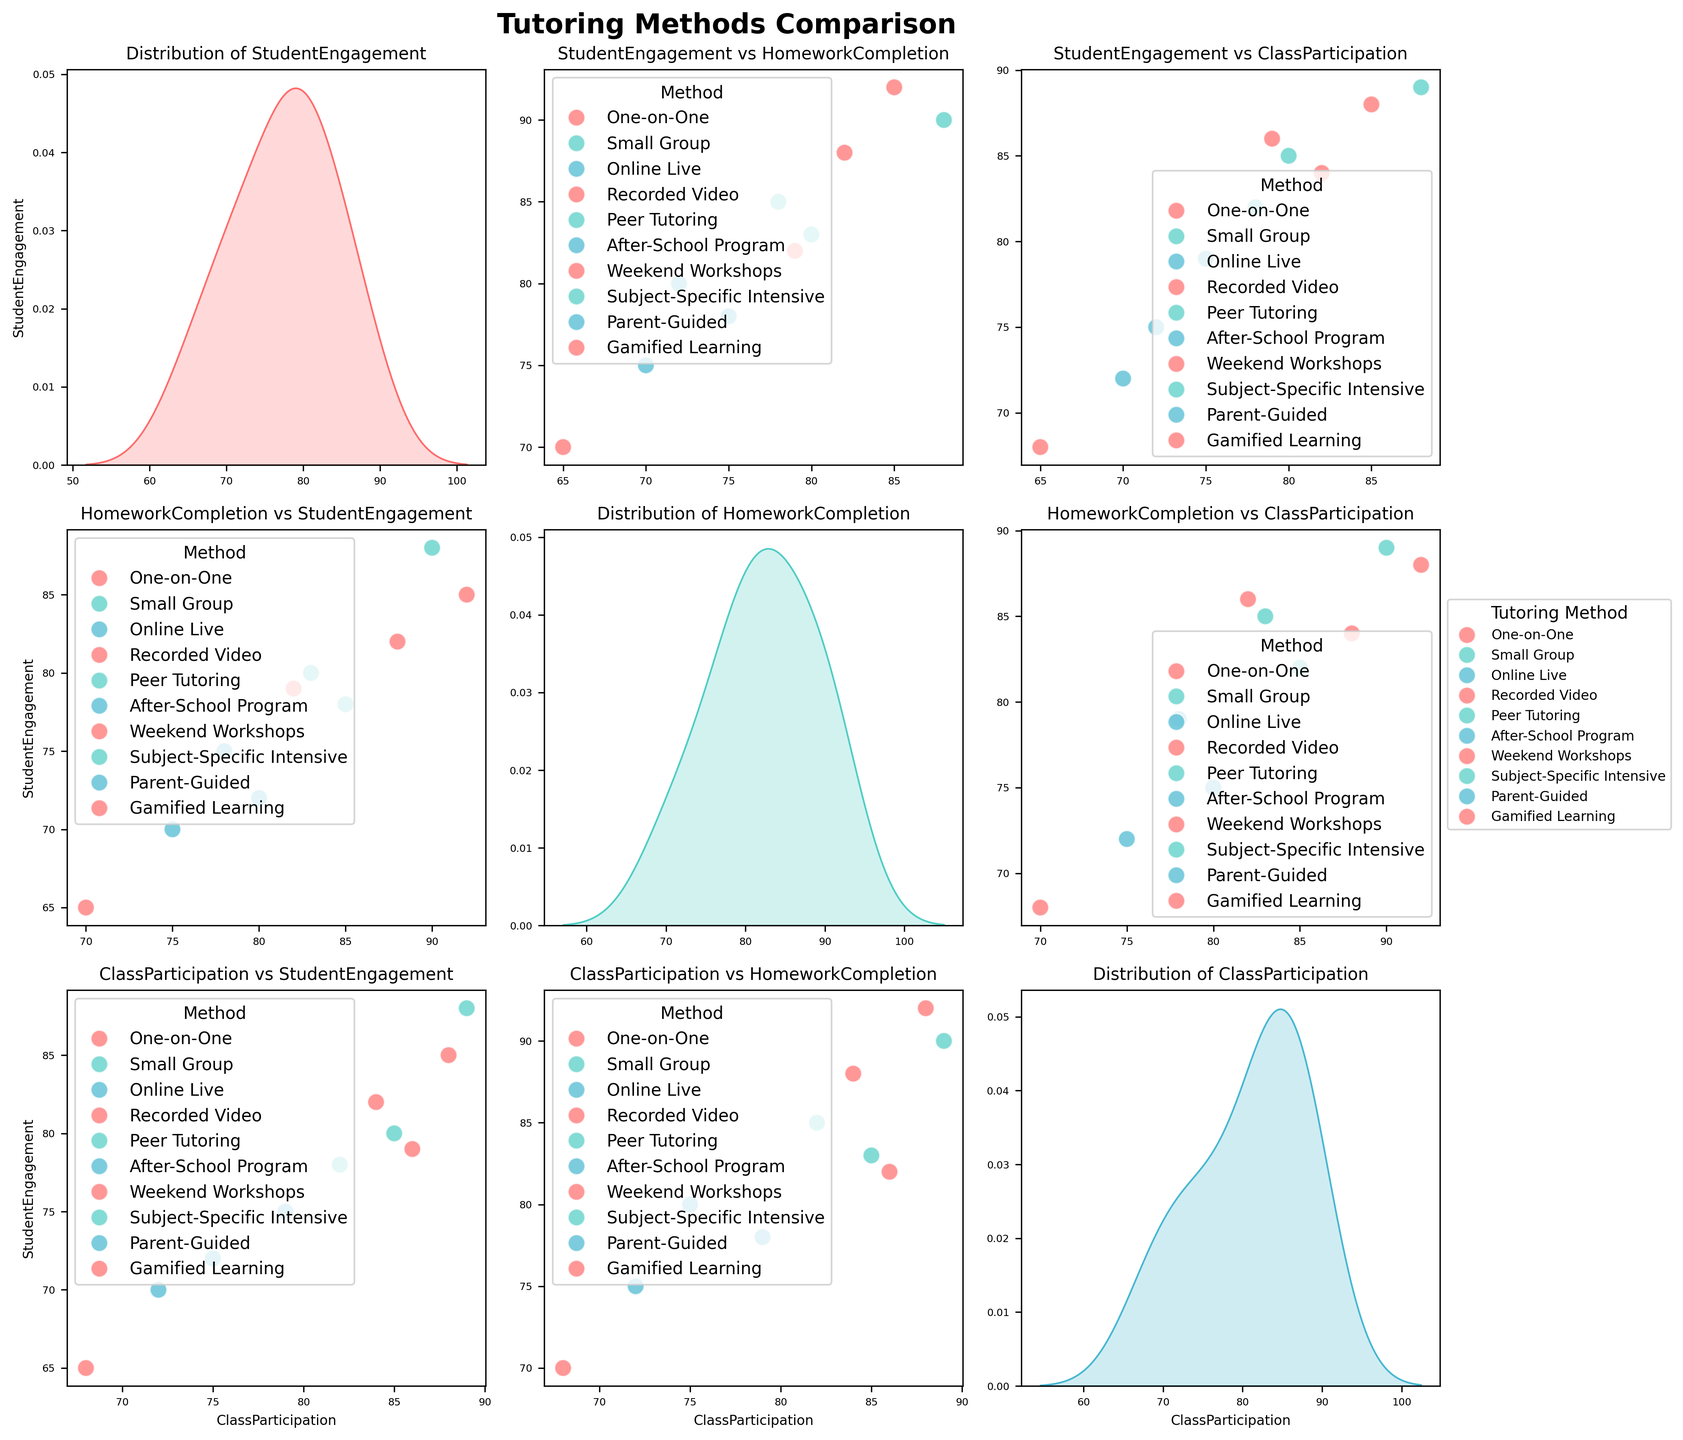What's the title of the figure? The title of the figure is written at the top, and it states "Tutoring Methods Comparison."
Answer: Tutoring Methods Comparison How many tutoring methods are compared in this scatterplot matrix? There are individual data points for each method in different parts of the plot, and each point is distinguished by its color and legend. Counting the labels in the legend, there are 10 tutoring methods.
Answer: 10 Which tutoring method has the highest student engagement? By observing the Student Engagement vs. other variables plots, the method with the highest engagement has a point close to 90. Checking the legend, Subject-Specific Intensive is highest with an engagement of 88.
Answer: Subject-Specific Intensive How does the class participation of Small Group compare to One-on-One? In the scatterplots where both Small Group and One-on-One appear, we see that Small Group has a class participation of 82, while One-on-One has 88. Thus, One-on-One has higher class participation.
Answer: One-on-One has higher Which two methods show the most similar trends in all three metrics: student engagement, homework completion, and class participation? Observing the scatterplots where data points cluster close to one another for both student engagement against homework completion and class participation, Peer Tutoring and Gamified Learning appear frequently close together in all combinations.
Answer: Peer Tutoring and Gamified Learning What is the average homework completion rate across all methods? The homework completion rates for all methods are: 92, 85, 80, 70, 83, 78, 88, 90, 75, 82. Summing these up yields 823. Dividing by the 10 methods gives an average of 823/10 = 82.3.
Answer: 82.3 Which method shows the lowest level of student engagement? Observing the Student Engagement distributions, the lowest value is near 65. The method associated with this value is Recorded Video.
Answer: Recorded Video What kind of point pattern or spread do you observe in the Student Engagement vs. Homework Completion plot? In the scatter plot of Student Engagement vs. Homework Completion, we see that the points show a positive trend, indicating that higher engagement correlates with higher homework completion rates, though there's some spread.
Answer: Positive correlation with some spread How does Online Live compare to Weekend Workshops in terms of class participation? By looking at the Class Participation values, Online Live has a value of 75, while Weekend Workshops has 84. Thus, Weekend Workshops has higher class participation.
Answer: Weekend Workshops has higher What would you infer about Subject-Specific Intensive's overall performance based on its position in various plots? Subject-Specific Intensive can be seen having high values in student engagement (88), homework completion (90), and class participation (89). This indicates it performs exceptionally well across all three metrics.
Answer: Exceptionally well across all three metrics 